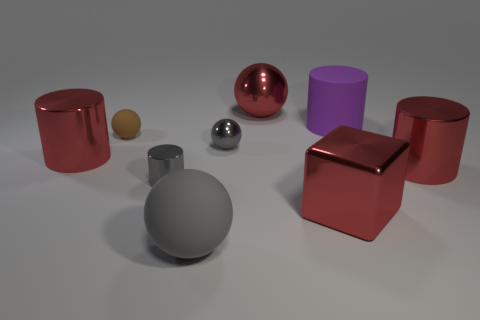Do the cube and the large purple object have the same material? From the image, the cube appears to have a reflective surface similar to metal, while the large purple object has a matte finish. Although they share similar geometric simplicity, the variation in their sheens suggests that they are made of different materials. 